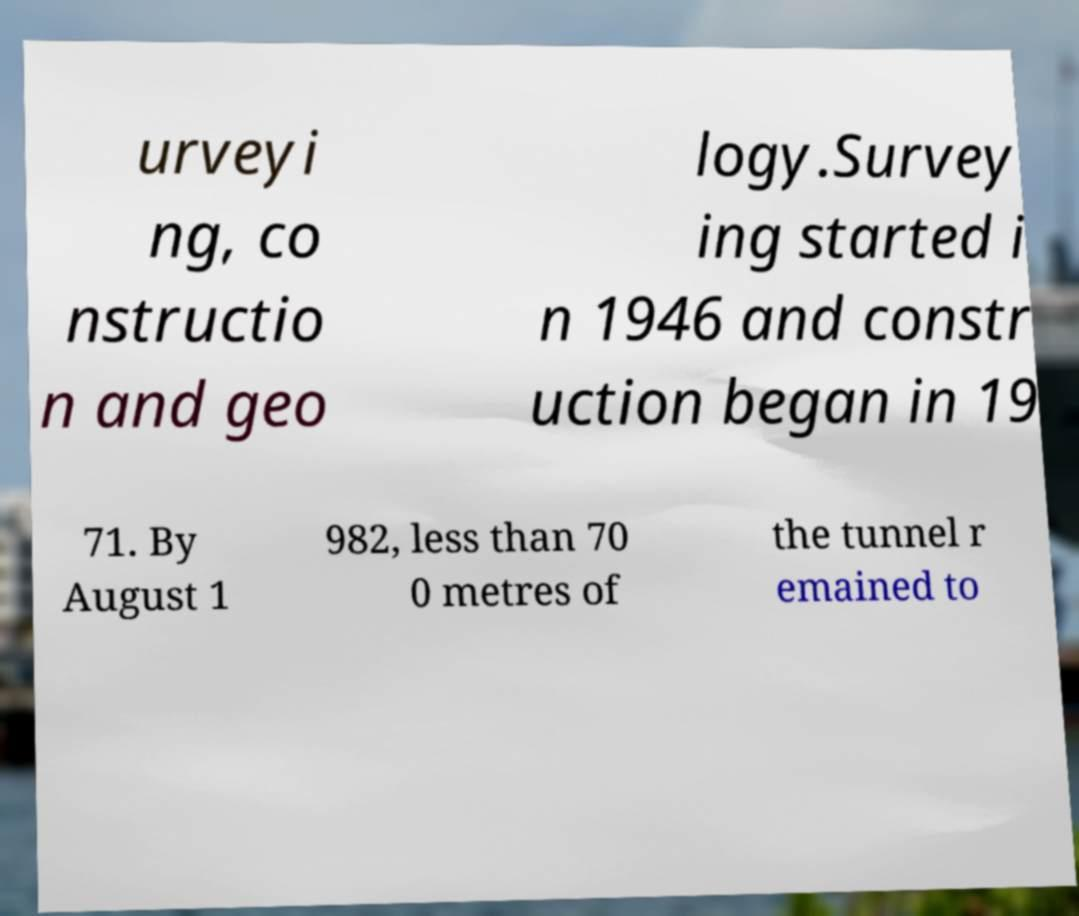For documentation purposes, I need the text within this image transcribed. Could you provide that? urveyi ng, co nstructio n and geo logy.Survey ing started i n 1946 and constr uction began in 19 71. By August 1 982, less than 70 0 metres of the tunnel r emained to 